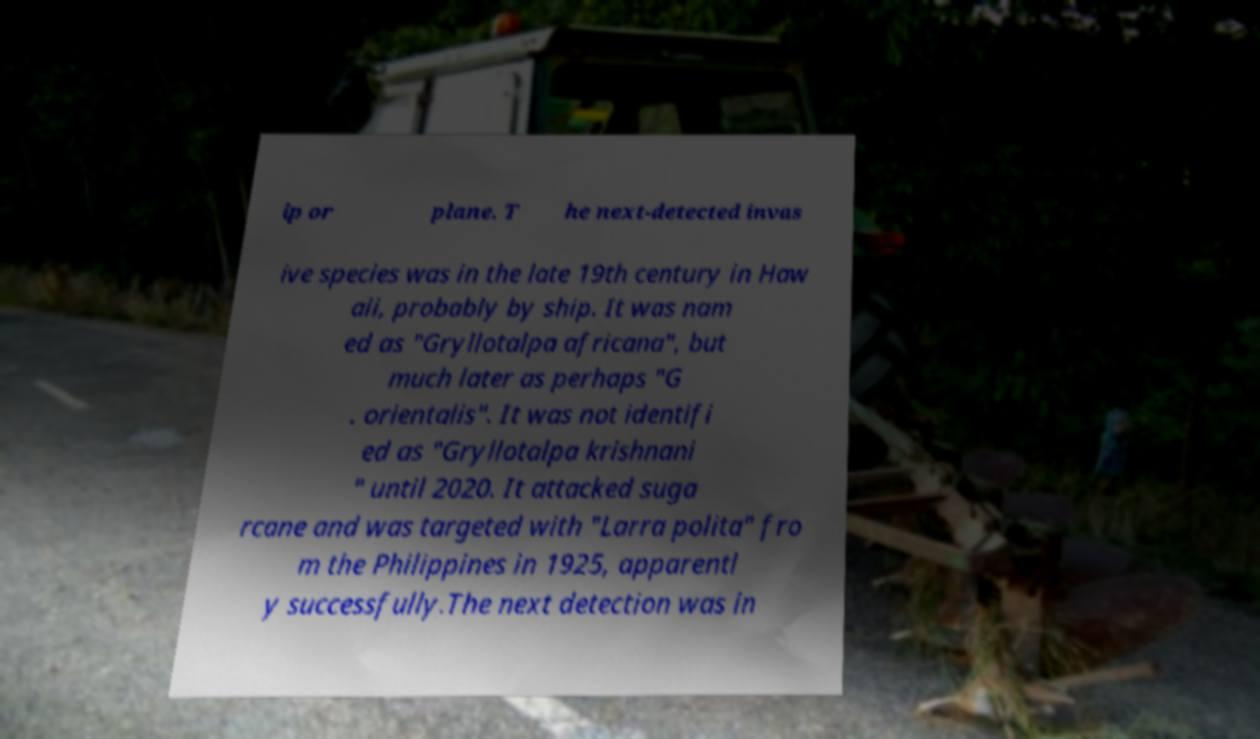Can you read and provide the text displayed in the image?This photo seems to have some interesting text. Can you extract and type it out for me? ip or plane. T he next-detected invas ive species was in the late 19th century in Haw aii, probably by ship. It was nam ed as "Gryllotalpa africana", but much later as perhaps "G . orientalis". It was not identifi ed as "Gryllotalpa krishnani " until 2020. It attacked suga rcane and was targeted with "Larra polita" fro m the Philippines in 1925, apparentl y successfully.The next detection was in 